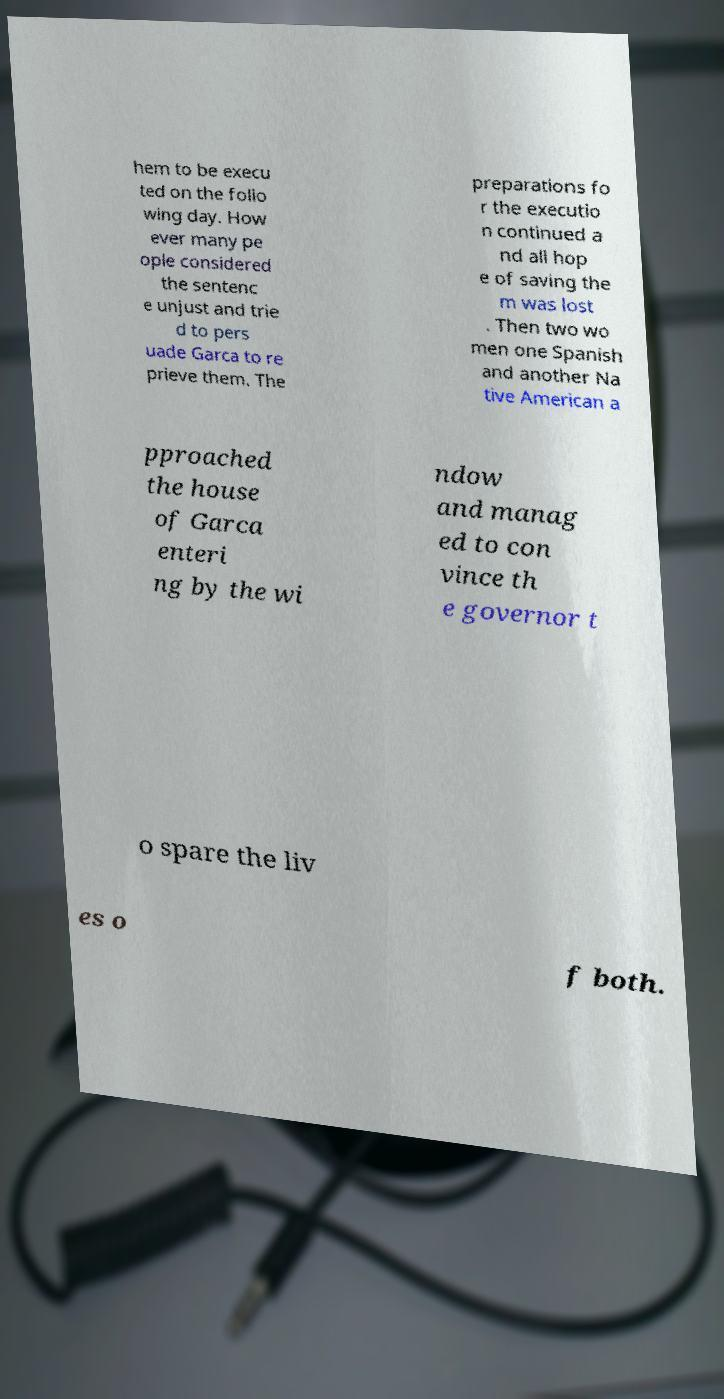There's text embedded in this image that I need extracted. Can you transcribe it verbatim? hem to be execu ted on the follo wing day. How ever many pe ople considered the sentenc e unjust and trie d to pers uade Garca to re prieve them. The preparations fo r the executio n continued a nd all hop e of saving the m was lost . Then two wo men one Spanish and another Na tive American a pproached the house of Garca enteri ng by the wi ndow and manag ed to con vince th e governor t o spare the liv es o f both. 